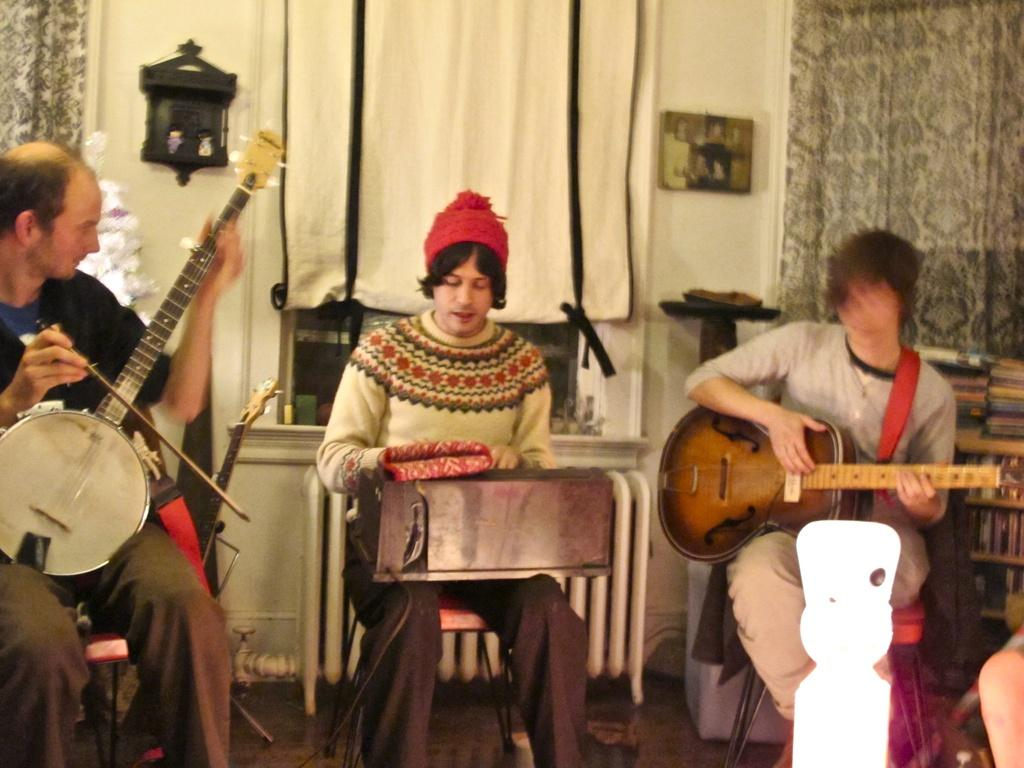How many people are in the image? There are three men in the image. What are the men doing in the image? The men are playing a guitar. Where are the men sitting in the image? The men are sitting on a chair. What type of nut is being used as a pick for the guitar in the image? There is no nut being used as a pick for the guitar in the image. Are the men wearing masks while playing the guitar in the image? No, the men are not wearing masks in the image. 